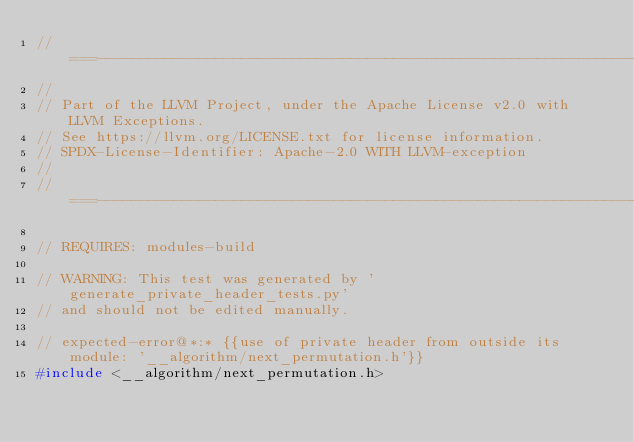<code> <loc_0><loc_0><loc_500><loc_500><_C++_>//===----------------------------------------------------------------------===//
//
// Part of the LLVM Project, under the Apache License v2.0 with LLVM Exceptions.
// See https://llvm.org/LICENSE.txt for license information.
// SPDX-License-Identifier: Apache-2.0 WITH LLVM-exception
//
//===----------------------------------------------------------------------===//

// REQUIRES: modules-build

// WARNING: This test was generated by 'generate_private_header_tests.py'
// and should not be edited manually.

// expected-error@*:* {{use of private header from outside its module: '__algorithm/next_permutation.h'}}
#include <__algorithm/next_permutation.h>
</code> 